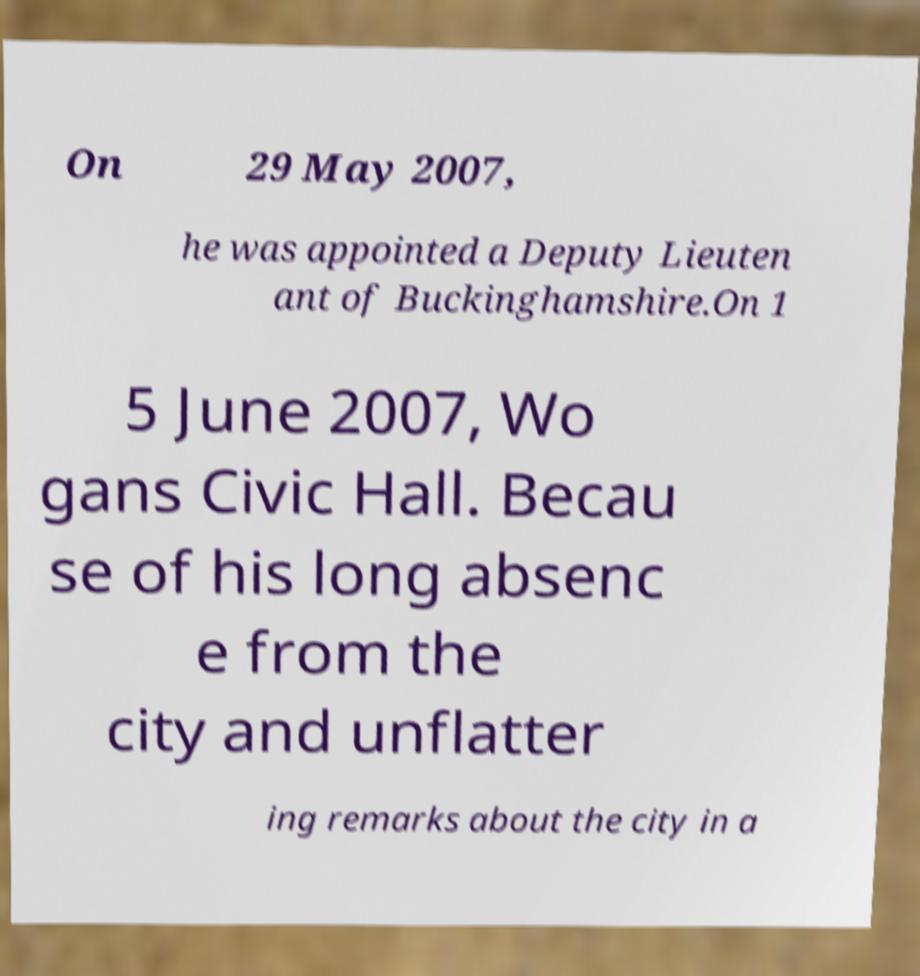Can you accurately transcribe the text from the provided image for me? On 29 May 2007, he was appointed a Deputy Lieuten ant of Buckinghamshire.On 1 5 June 2007, Wo gans Civic Hall. Becau se of his long absenc e from the city and unflatter ing remarks about the city in a 